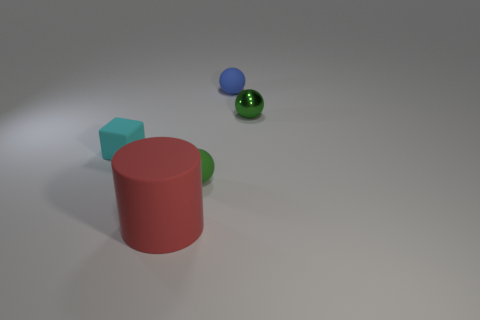There is a rubber sphere right of the rubber ball in front of the small cyan cube; what color is it?
Make the answer very short. Blue. What is the material of the small ball that is both behind the cyan object and in front of the blue thing?
Make the answer very short. Metal. Are there any other things that have the same shape as the cyan object?
Offer a terse response. No. Do the tiny green thing behind the cyan cube and the blue object have the same shape?
Ensure brevity in your answer.  Yes. What number of tiny green things are both in front of the cyan block and on the right side of the blue rubber thing?
Keep it short and to the point. 0. There is a small object to the left of the big red rubber object; what shape is it?
Your answer should be very brief. Cube. How many blue objects are the same material as the tiny block?
Offer a very short reply. 1. There is a tiny blue matte object; does it have the same shape as the tiny rubber object that is left of the rubber cylinder?
Give a very brief answer. No. There is a tiny green ball in front of the green thing behind the rubber block; is there a blue rubber object in front of it?
Ensure brevity in your answer.  No. There is a green thing on the left side of the blue sphere; what is its size?
Offer a terse response. Small. 